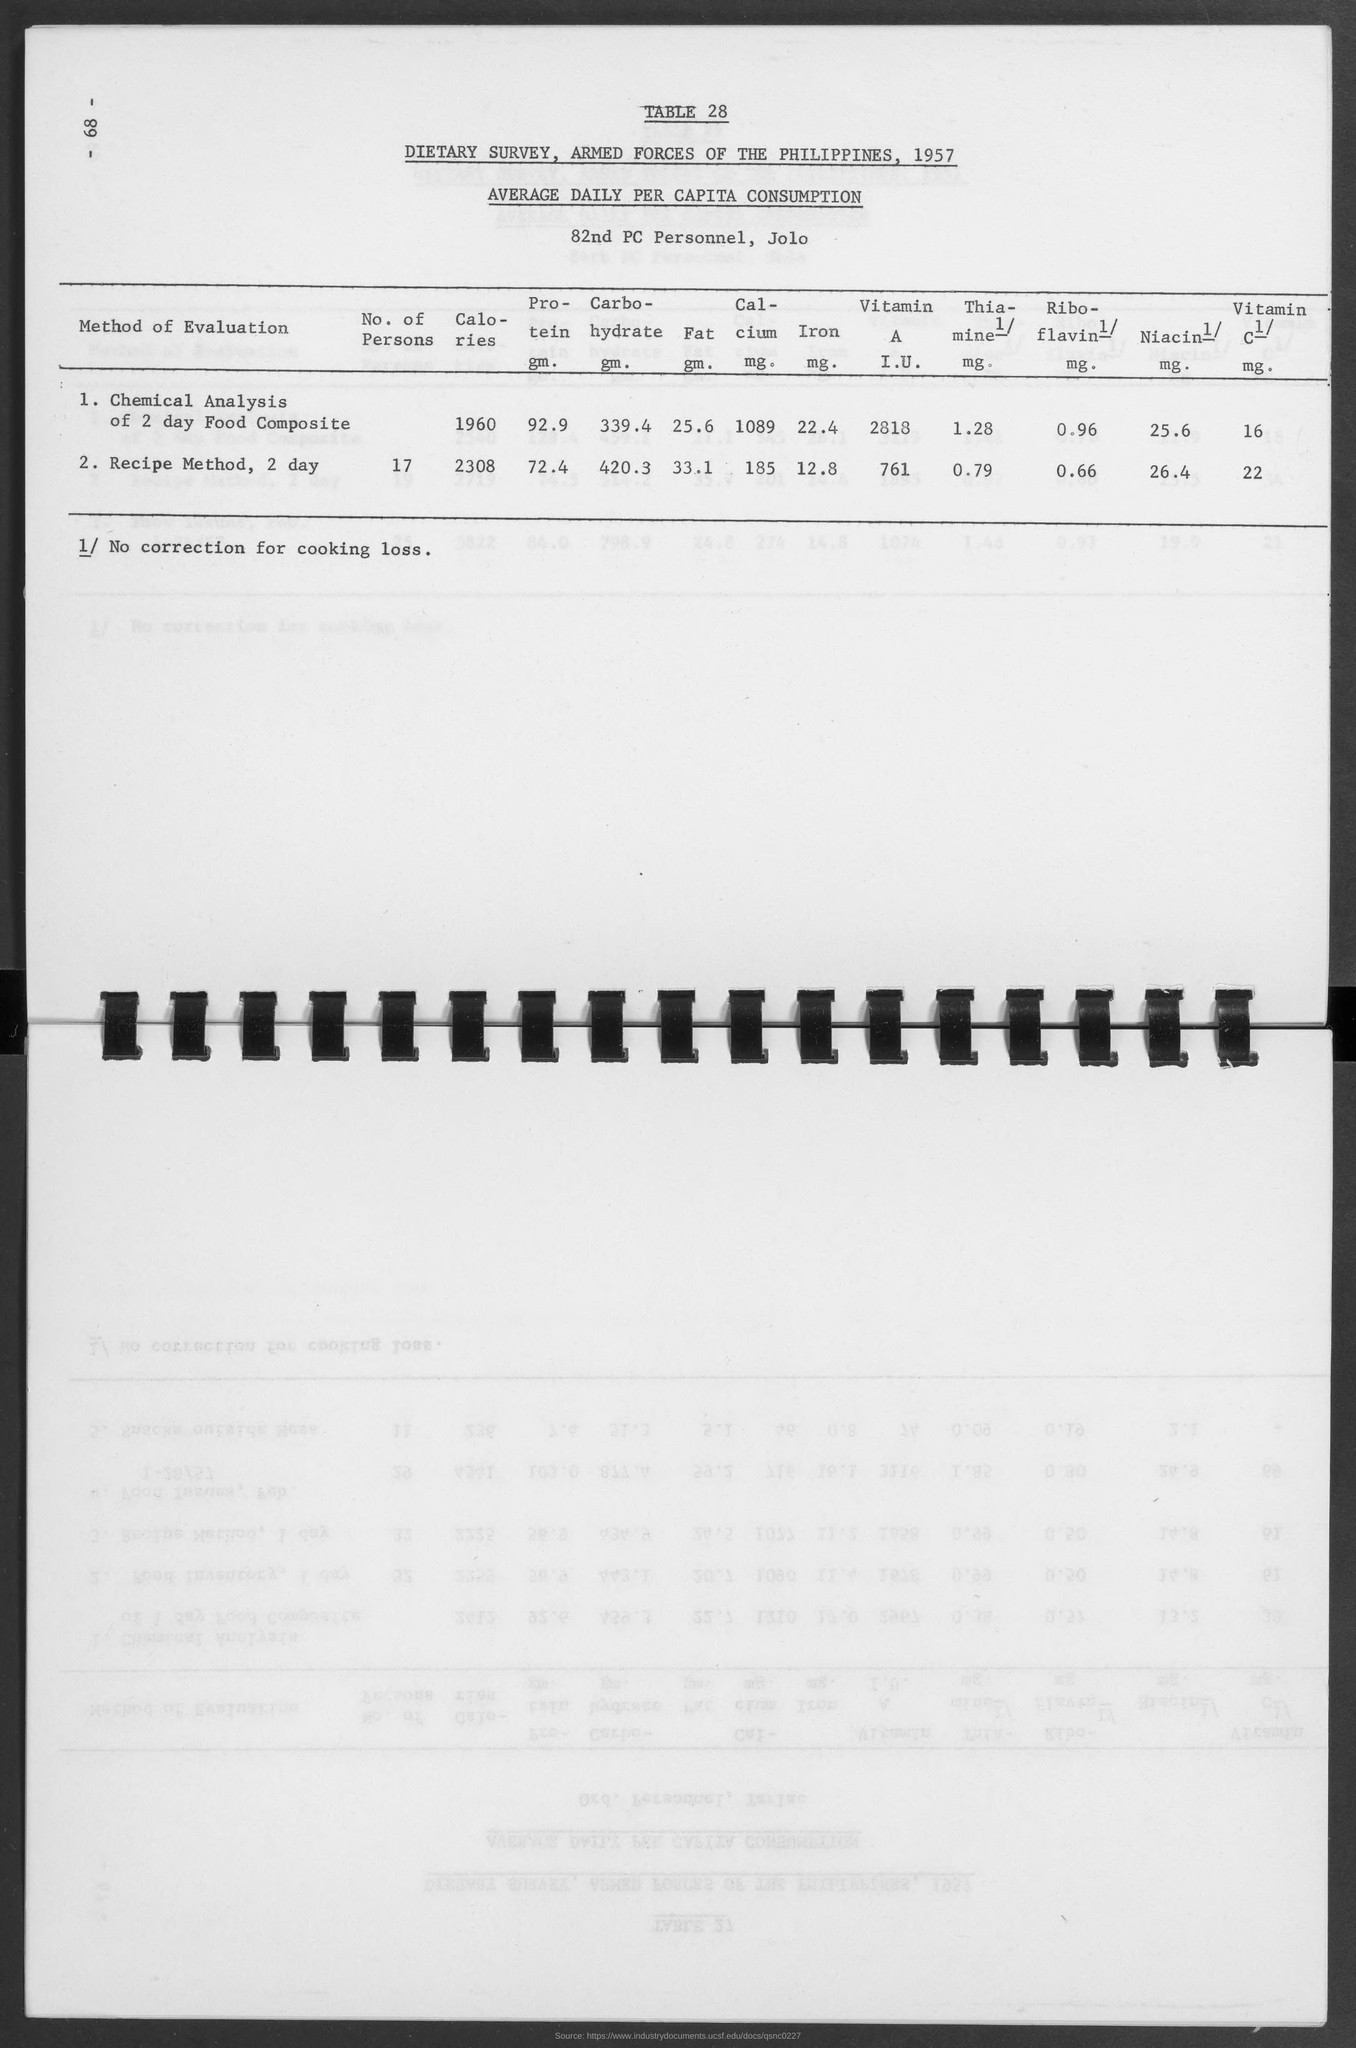What are the calories for chemical anlysis of 2 day food composite?
Your response must be concise. 1960. What are the Protein gm. for chemical anlysis of 2 day food composite?
Your response must be concise. 92.9. What are the Carbohydrate gm. for chemical anlysis of 2 day food composite?
Provide a succinct answer. 339.4. What are the Fat gm. for chemical anlysis of 2 day food composite?
Offer a very short reply. 25.6. What are the Calcium mg. for chemical anlysis of 2 day food composite?
Provide a short and direct response. 1089. What are the Iron mg for chemical anlysis of 2 day food composite?
Provide a short and direct response. 22.4. What are the Vitamin A I.U. for chemical anlysis of 2 day food composite?
Your answer should be very brief. 2818. What are the Riboflavin mg. for chemical anlysis of 2 day food composite?
Ensure brevity in your answer.  0.96. What are the Niacine mg. for chemical anlysis of 2 day food composite?
Ensure brevity in your answer.  25.6. 